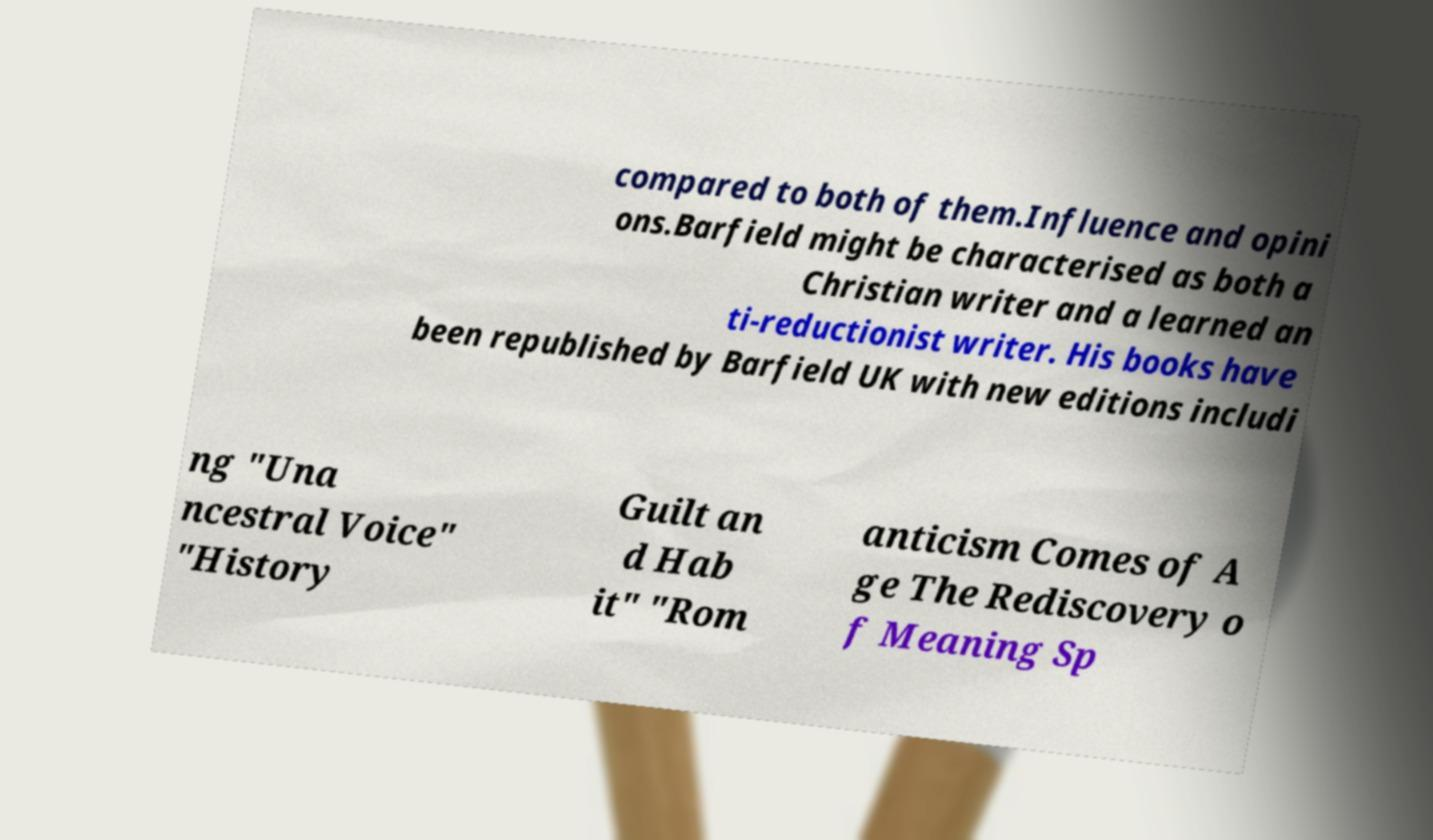I need the written content from this picture converted into text. Can you do that? compared to both of them.Influence and opini ons.Barfield might be characterised as both a Christian writer and a learned an ti-reductionist writer. His books have been republished by Barfield UK with new editions includi ng "Una ncestral Voice" "History Guilt an d Hab it" "Rom anticism Comes of A ge The Rediscovery o f Meaning Sp 